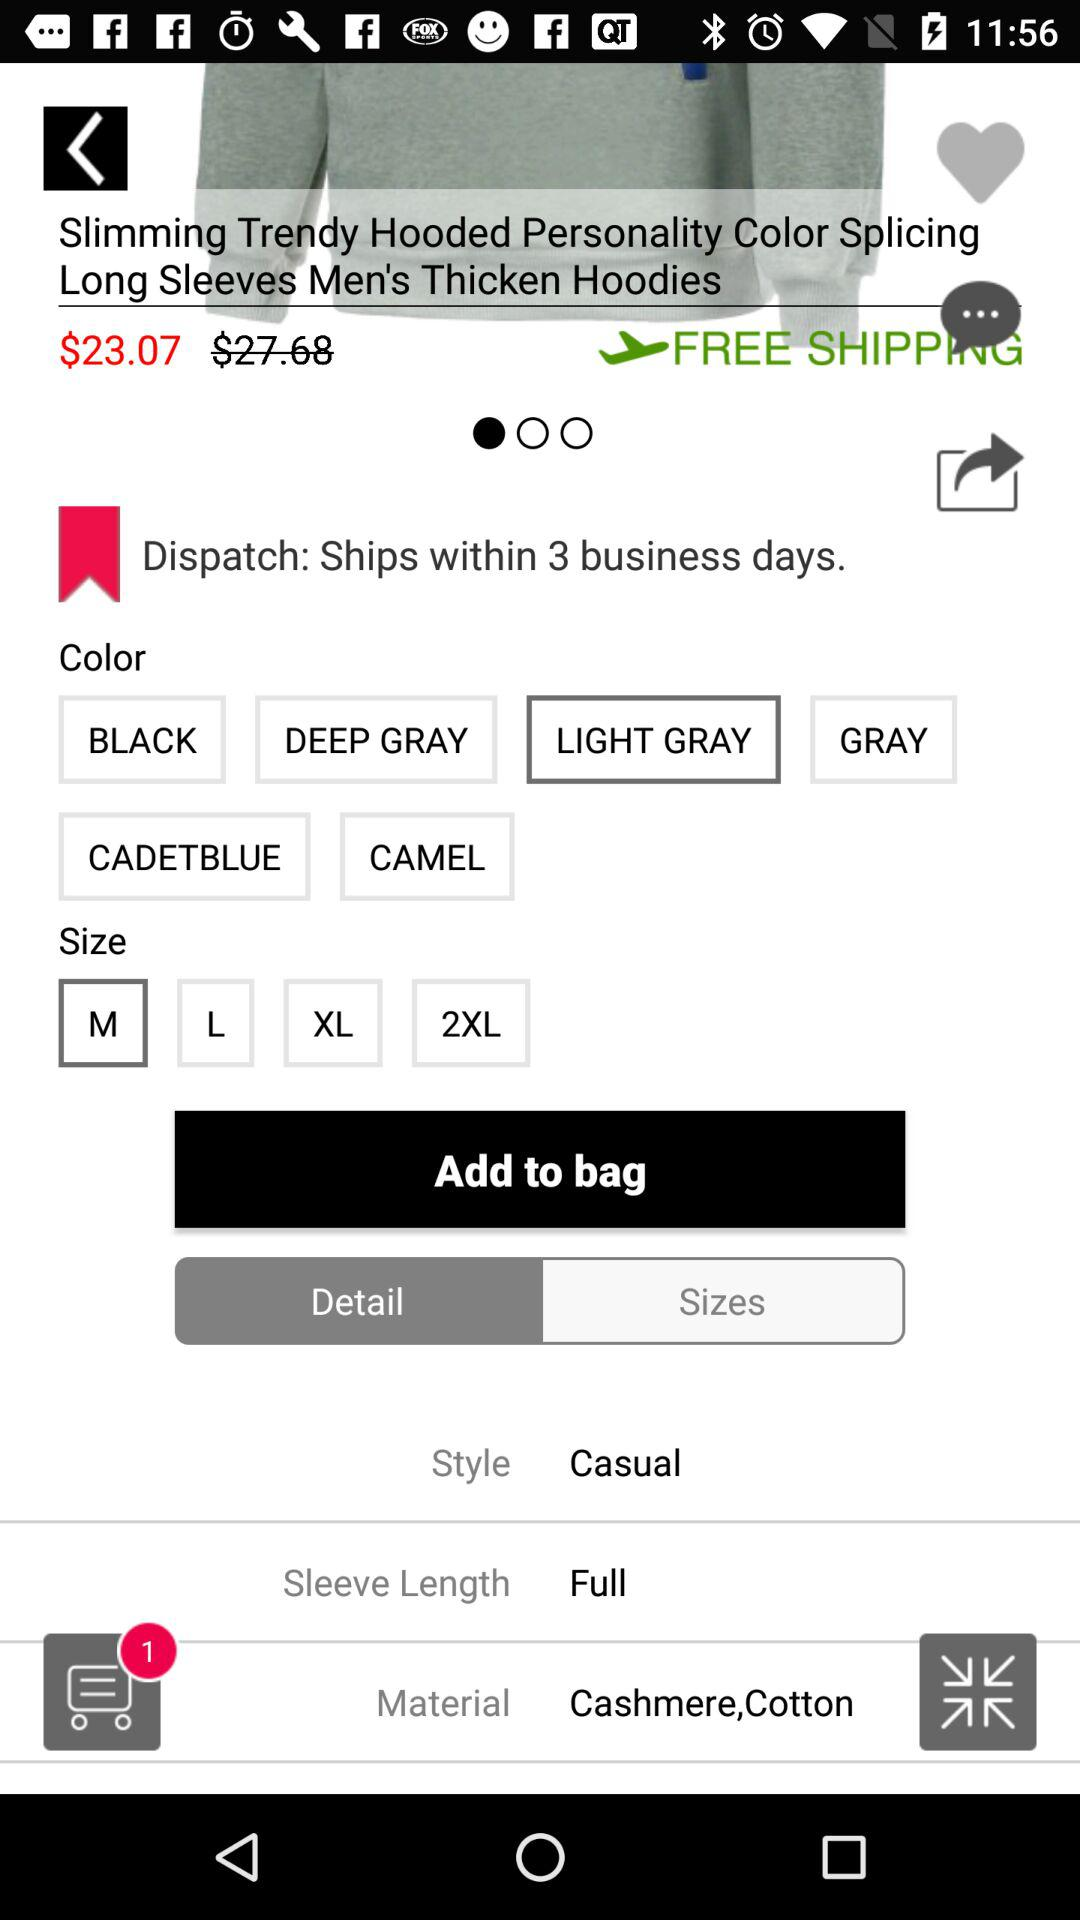Which size is selected? The selected size is medium. 